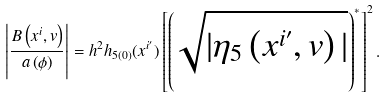<formula> <loc_0><loc_0><loc_500><loc_500>\left | \frac { B \left ( x ^ { i } , v \right ) } { a \left ( \phi \right ) } \right | = h ^ { 2 } h _ { 5 ( 0 ) } ( x ^ { i ^ { \prime } } ) \left [ \left ( \sqrt { | \eta _ { 5 } \left ( x ^ { i ^ { \prime } } , v \right ) | } \right ) ^ { \ast } \right ] ^ { 2 } .</formula> 